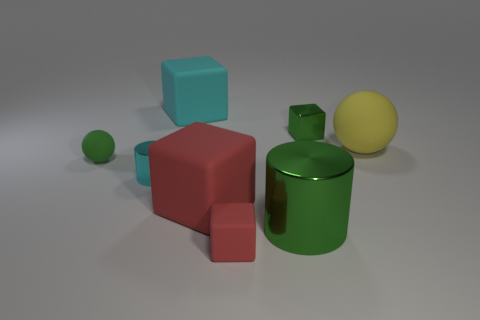There is a green thing that is the same shape as the large cyan rubber object; what size is it?
Provide a short and direct response. Small. Are there fewer large green cylinders that are on the left side of the small green matte sphere than large yellow objects to the left of the small green shiny object?
Provide a short and direct response. No. There is a green object that is behind the big metallic object and to the right of the tiny green matte thing; what shape is it?
Give a very brief answer. Cube. The yellow ball that is the same material as the cyan cube is what size?
Your answer should be compact. Large. Does the tiny matte block have the same color as the large matte thing behind the large matte ball?
Ensure brevity in your answer.  No. There is a green thing that is both to the right of the tiny red object and behind the tiny cyan object; what is its material?
Offer a very short reply. Metal. What size is the block that is the same color as the tiny cylinder?
Offer a very short reply. Large. Do the big rubber object in front of the small cyan shiny cylinder and the tiny green thing that is on the left side of the cyan matte block have the same shape?
Keep it short and to the point. No. Is there a tiny gray metal cube?
Provide a succinct answer. No. What is the color of the small rubber thing that is the same shape as the tiny green metal object?
Offer a terse response. Red. 